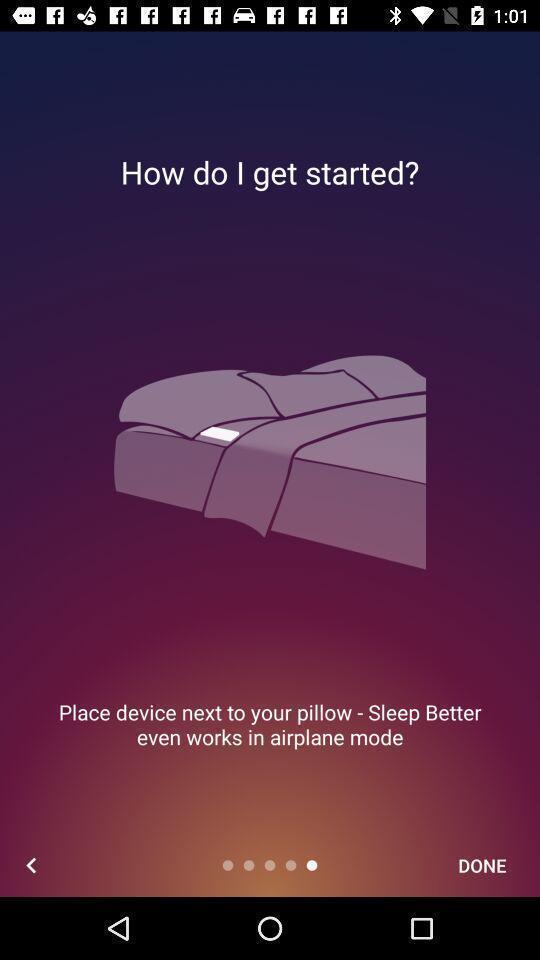Describe the content in this image. Page displays to start an application. 